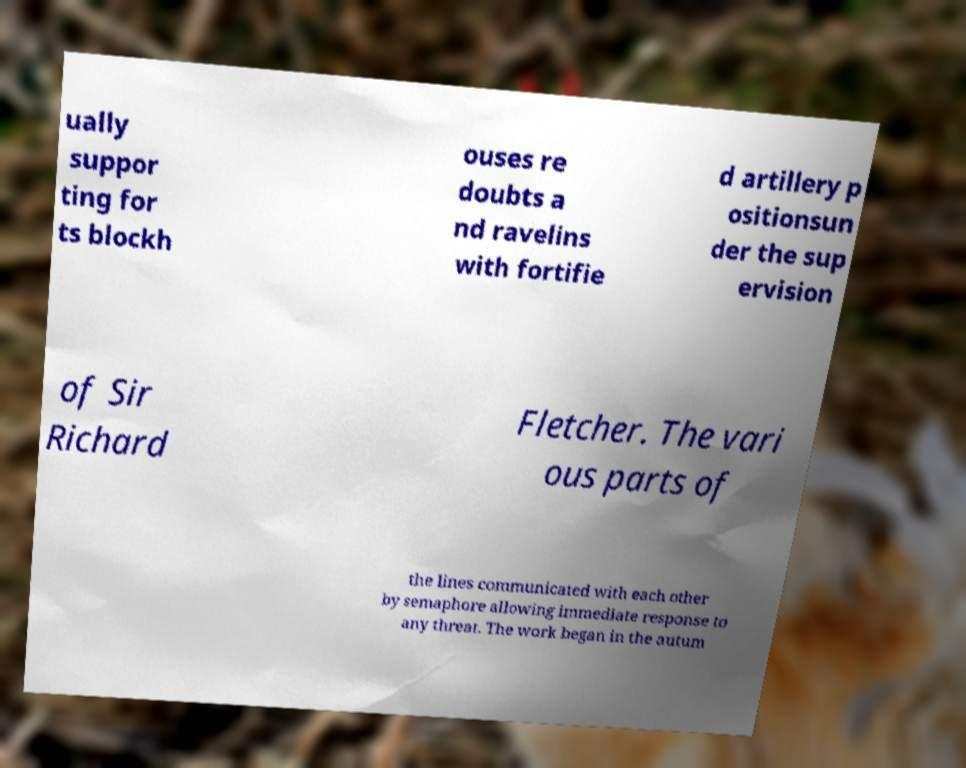I need the written content from this picture converted into text. Can you do that? ually suppor ting for ts blockh ouses re doubts a nd ravelins with fortifie d artillery p ositionsun der the sup ervision of Sir Richard Fletcher. The vari ous parts of the lines communicated with each other by semaphore allowing immediate response to any threat. The work began in the autum 